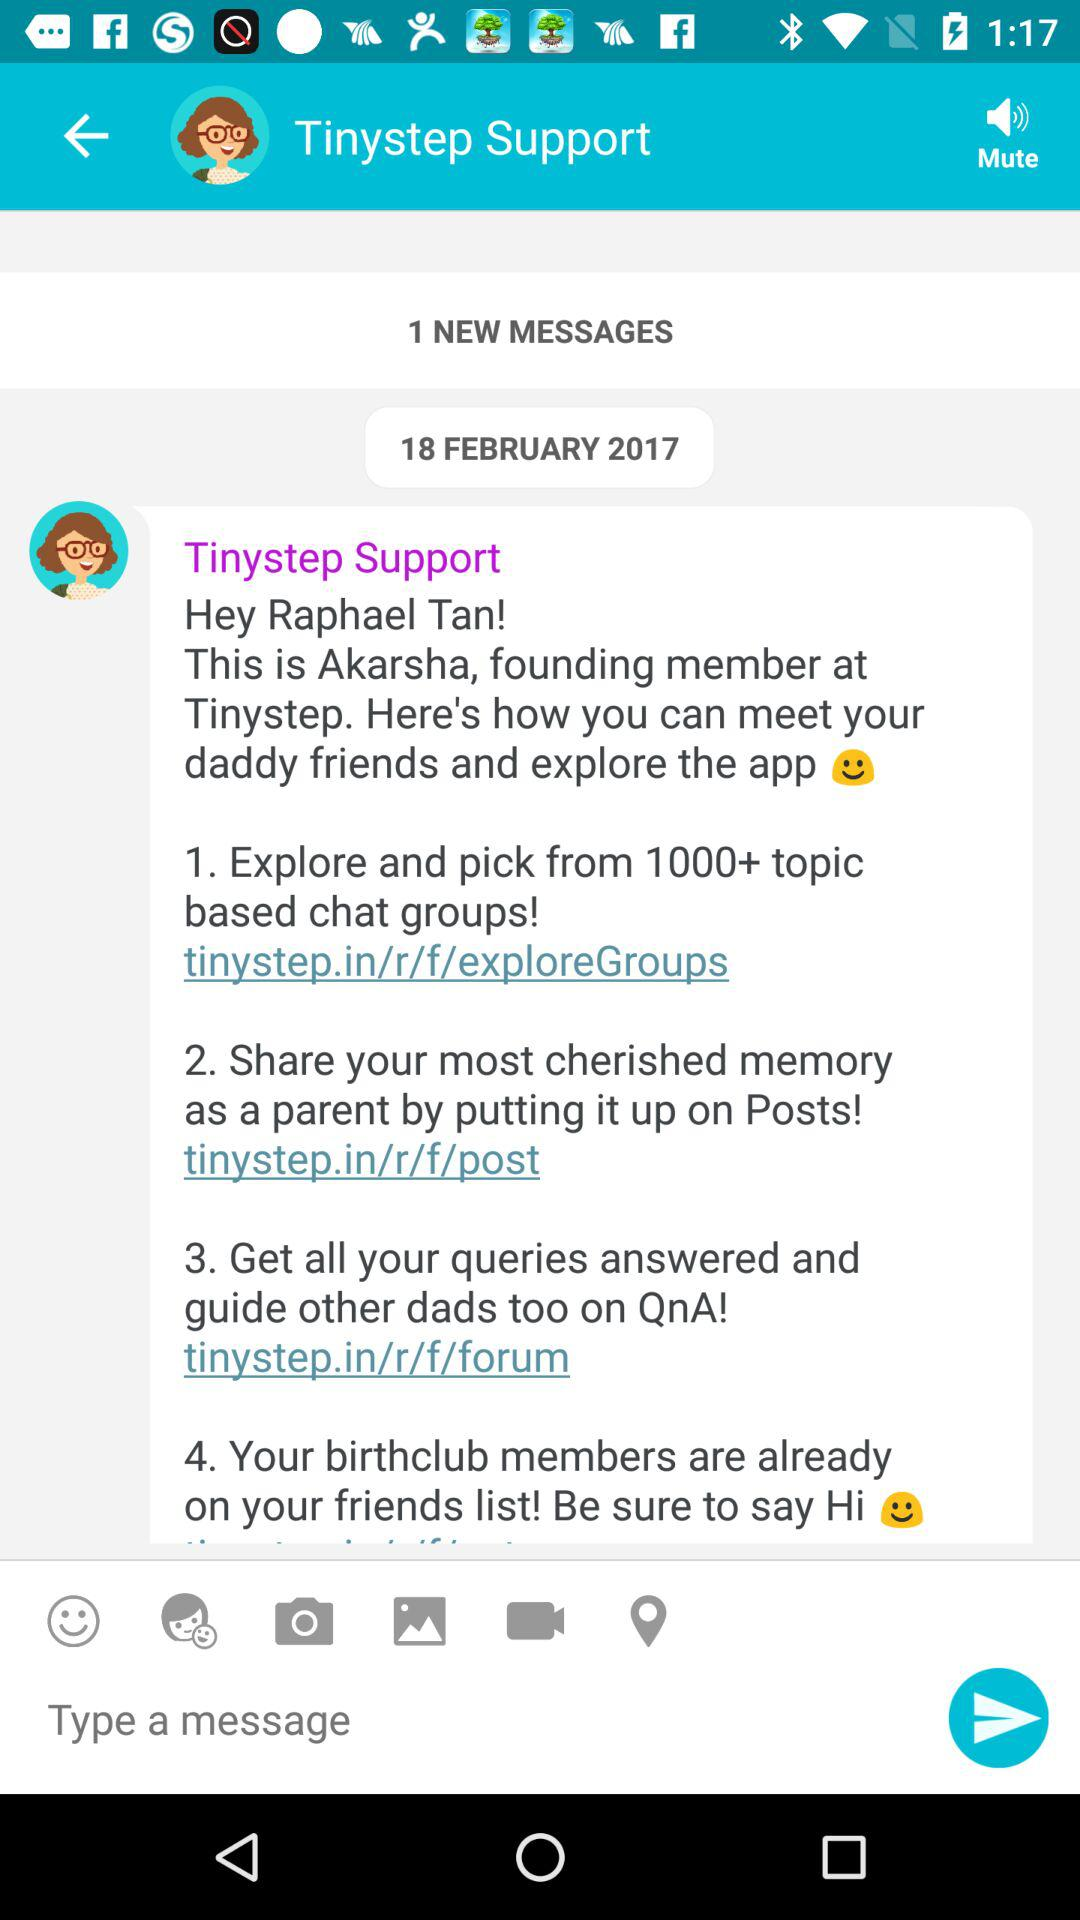How many messages does the user have unread?
Answer the question using a single word or phrase. 1 